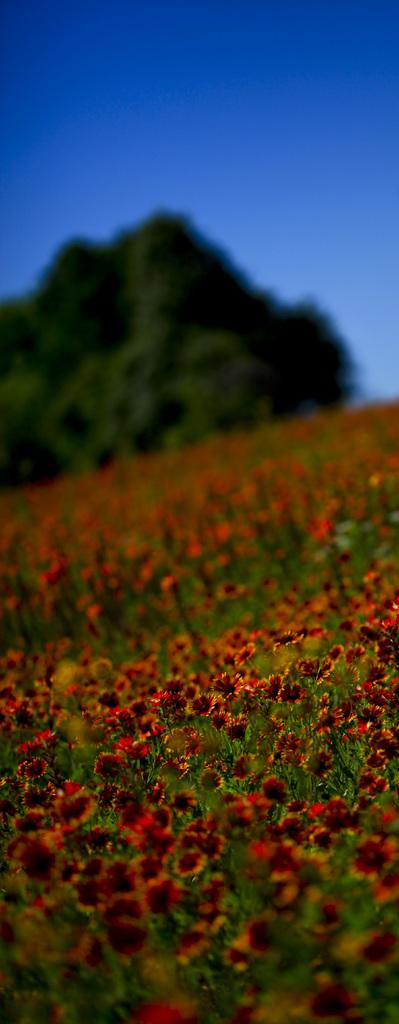What is the main subject of the image? The main subject of the image is many flowers. Where are the flowers located? The flowers are on plants. Can you describe the background of the image? The background of the image is blurred, and there are trees and a blue sky visible. What type of structure can be seen holding the flowers in the image? There is no structure holding the flowers in the image; they are on plants. How does the person in the image grip the flowers? There is no person present in the image, so it is not possible to determine how they might grip the flowers. 